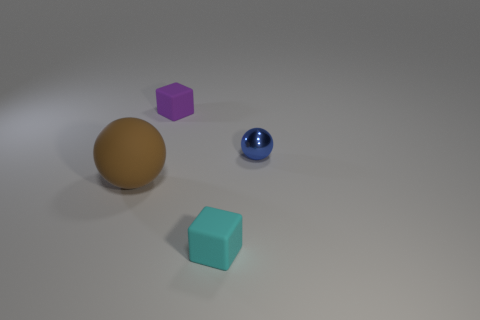Is there any other thing that is made of the same material as the blue object?
Offer a terse response. No. Are there fewer tiny rubber blocks than yellow metal balls?
Your answer should be compact. No. What number of other objects are the same color as the shiny object?
Your answer should be compact. 0. Is the small block behind the small blue ball made of the same material as the small blue object?
Keep it short and to the point. No. There is a tiny block in front of the small purple object; what material is it?
Offer a very short reply. Rubber. There is a blue shiny sphere that is in front of the tiny rubber object that is behind the small sphere; how big is it?
Keep it short and to the point. Small. Are there any large objects made of the same material as the large sphere?
Your response must be concise. No. There is a thing right of the small object that is in front of the object that is left of the purple cube; what shape is it?
Your answer should be compact. Sphere. There is a sphere on the left side of the blue ball; does it have the same color as the small block that is left of the cyan matte object?
Your answer should be very brief. No. Is there anything else that has the same size as the cyan matte block?
Ensure brevity in your answer.  Yes. 